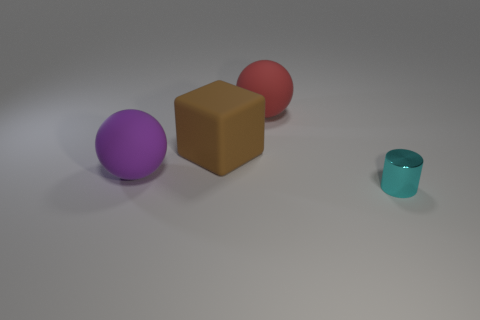Add 2 cyan cylinders. How many objects exist? 6 Subtract all cylinders. How many objects are left? 3 Add 4 cylinders. How many cylinders are left? 5 Add 3 big red rubber spheres. How many big red rubber spheres exist? 4 Subtract 0 green spheres. How many objects are left? 4 Subtract all red cubes. Subtract all red balls. How many cubes are left? 1 Subtract all big red spheres. Subtract all big cyan rubber blocks. How many objects are left? 3 